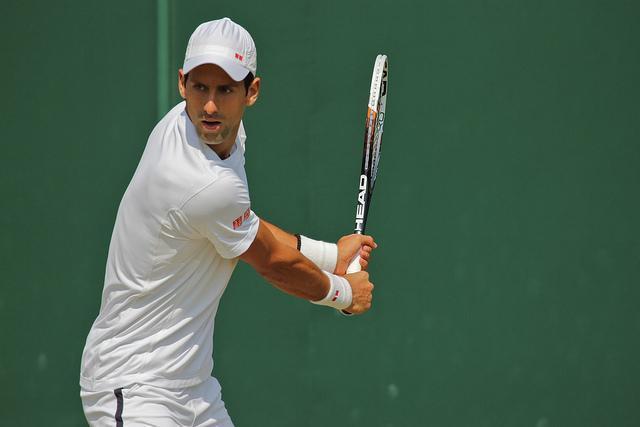How many wristbands does the man have on?
Give a very brief answer. 2. 